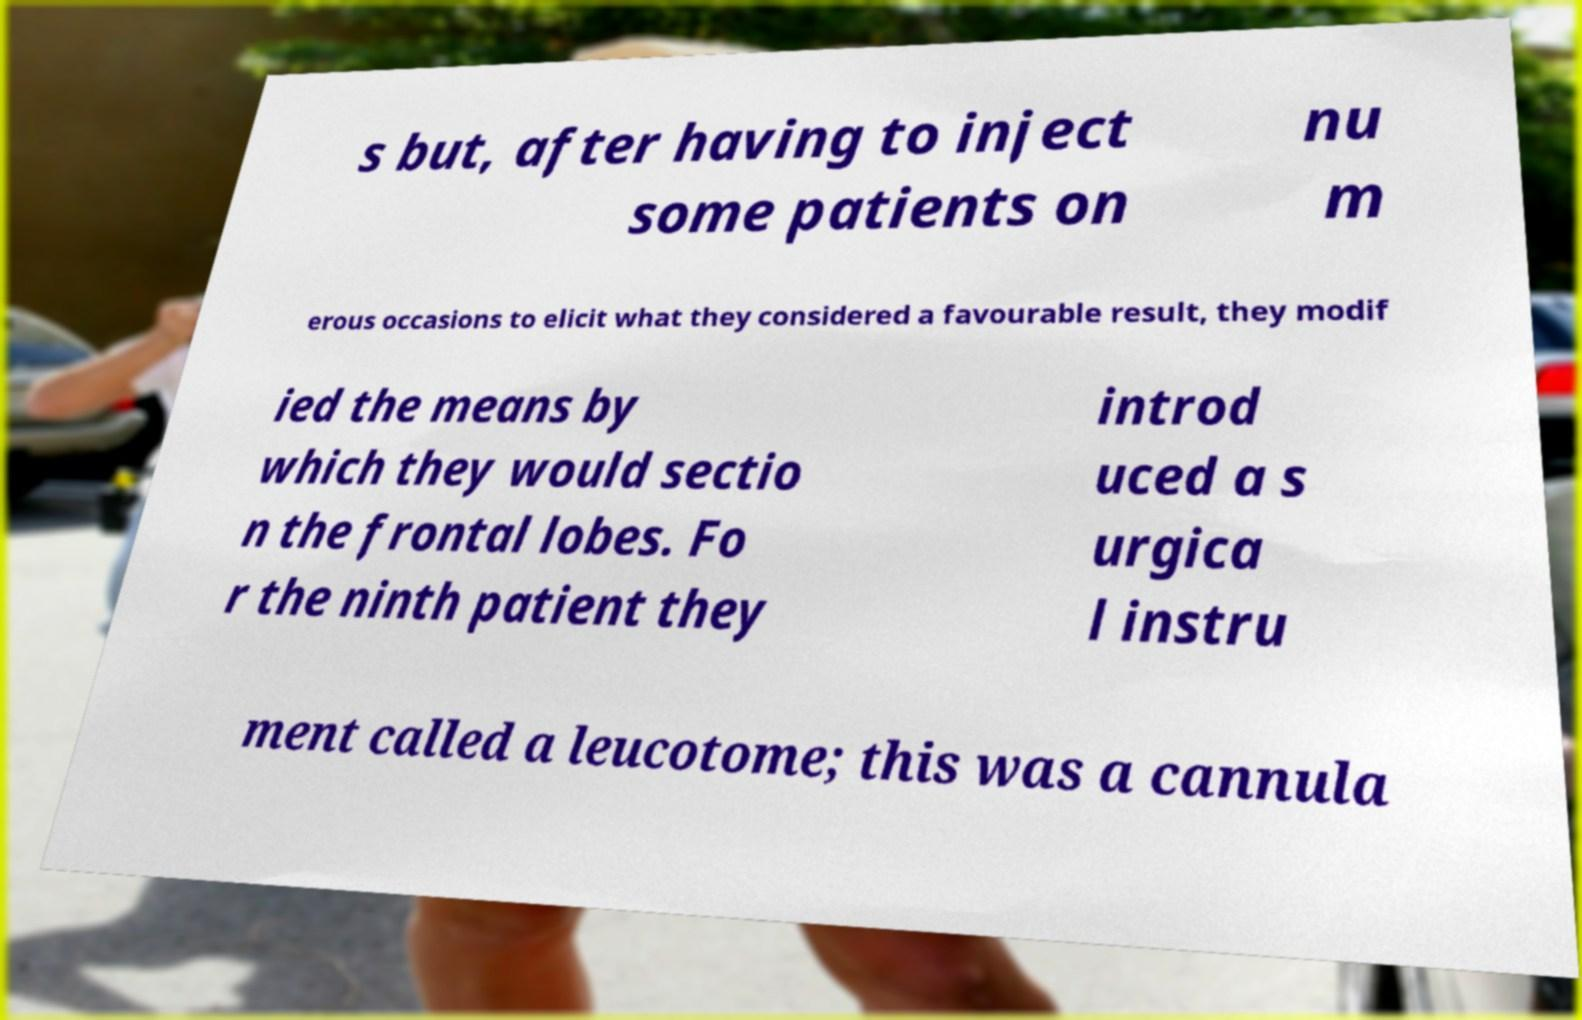Could you extract and type out the text from this image? s but, after having to inject some patients on nu m erous occasions to elicit what they considered a favourable result, they modif ied the means by which they would sectio n the frontal lobes. Fo r the ninth patient they introd uced a s urgica l instru ment called a leucotome; this was a cannula 